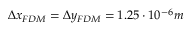Convert formula to latex. <formula><loc_0><loc_0><loc_500><loc_500>\Delta x _ { F D M } = \Delta y _ { F D M } = 1 . 2 5 \cdot 1 0 ^ { - 6 } m</formula> 